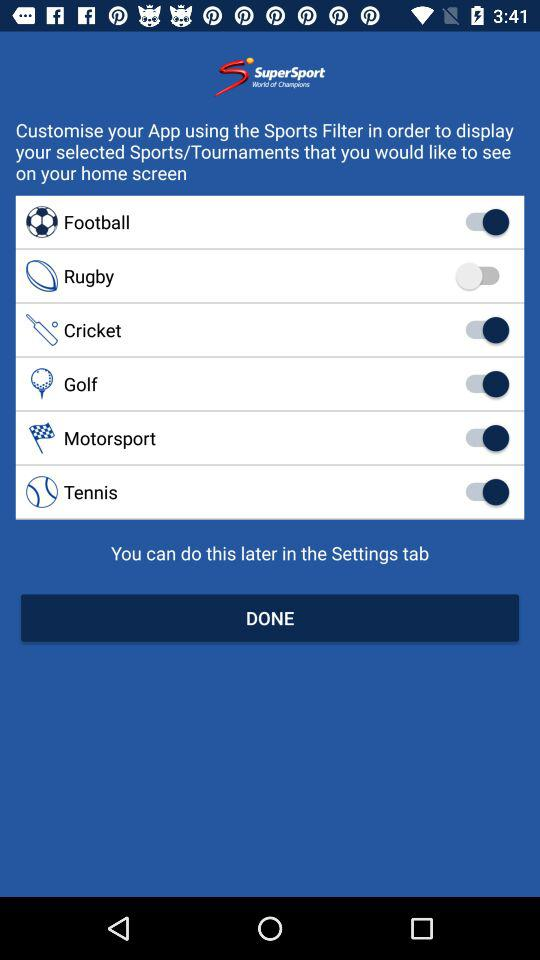How many sports are available for selection?
Answer the question using a single word or phrase. 6 